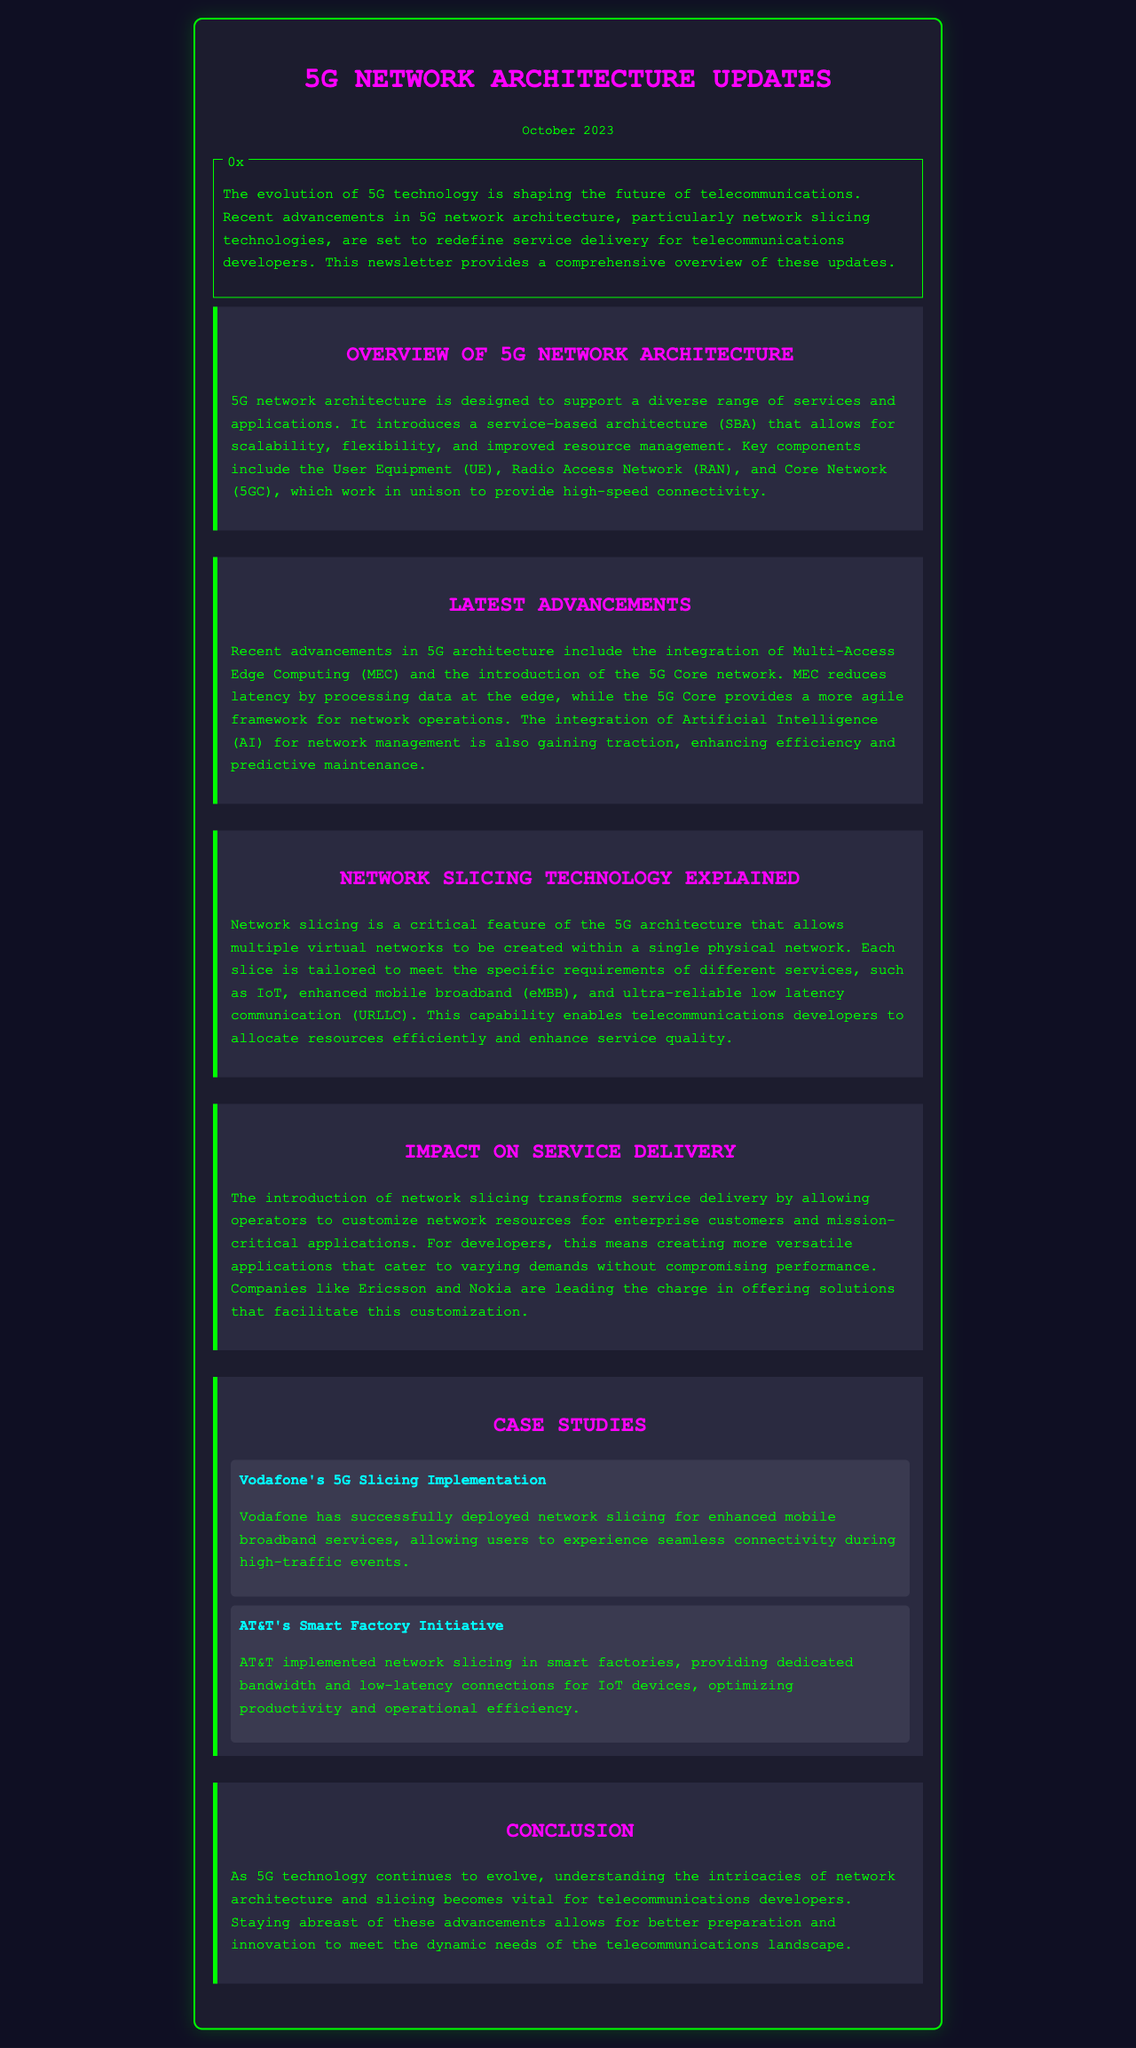What is the date of the newsletter? The date is displayed prominently at the top of the newsletter.
Answer: October 2023 What technology reduces latency in 5G architecture? The document mentions that Multi-Access Edge Computing (MEC) helps reduce latency.
Answer: MEC What does network slicing allow within a physical network? The section explains that network slicing enables multiple virtual networks to be created within a single physical network.
Answer: Multiple virtual networks Which companies are leading in providing solutions for network slicing? The document states that companies like Ericsson and Nokia are leading the charge.
Answer: Ericsson and Nokia What is the focus of Vodafone's 5G slicing implementation? Vodafone's focus is on enhanced mobile broadband services, particularly during high-traffic events.
Answer: Enhanced mobile broadband How does AT&T use network slicing in smart factories? The text outlines that AT&T provides dedicated bandwidth and low-latency connections for IoT devices in smart factories.
Answer: Dedicated bandwidth and low-latency connections What kind of architecture does 5G employ? The document indicates that 5G employs a service-based architecture (SBA).
Answer: Service-based architecture What is the main purpose of the newsletter? The newsletter aims to provide an overview of the latest advancements in 5G architecture.
Answer: Overview of advancements in 5G architecture What key component works alongside User Equipment (UE) and Radio Access Network (RAN) in 5G? The document identifies the Core Network (5GC) as a key component alongside UE and RAN.
Answer: Core Network (5GC) 